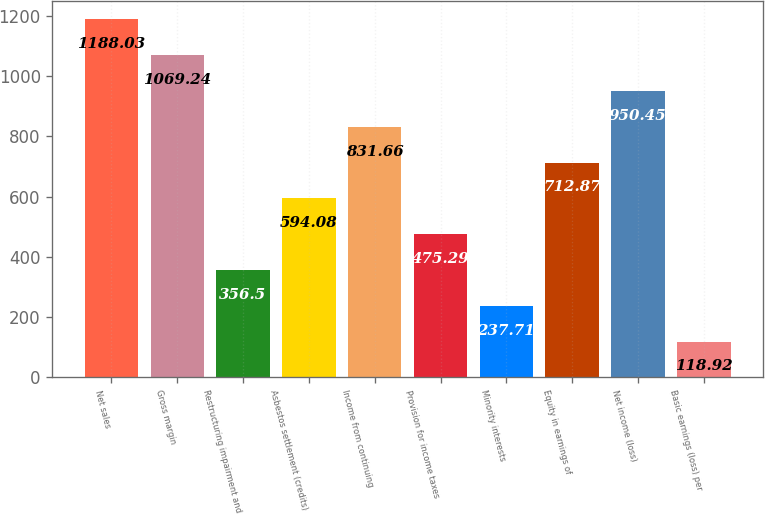Convert chart. <chart><loc_0><loc_0><loc_500><loc_500><bar_chart><fcel>Net sales<fcel>Gross margin<fcel>Restructuring impairment and<fcel>Asbestos settlement (credits)<fcel>Income from continuing<fcel>Provision for income taxes<fcel>Minority interests<fcel>Equity in earnings of<fcel>Net income (loss)<fcel>Basic earnings (loss) per<nl><fcel>1188.03<fcel>1069.24<fcel>356.5<fcel>594.08<fcel>831.66<fcel>475.29<fcel>237.71<fcel>712.87<fcel>950.45<fcel>118.92<nl></chart> 